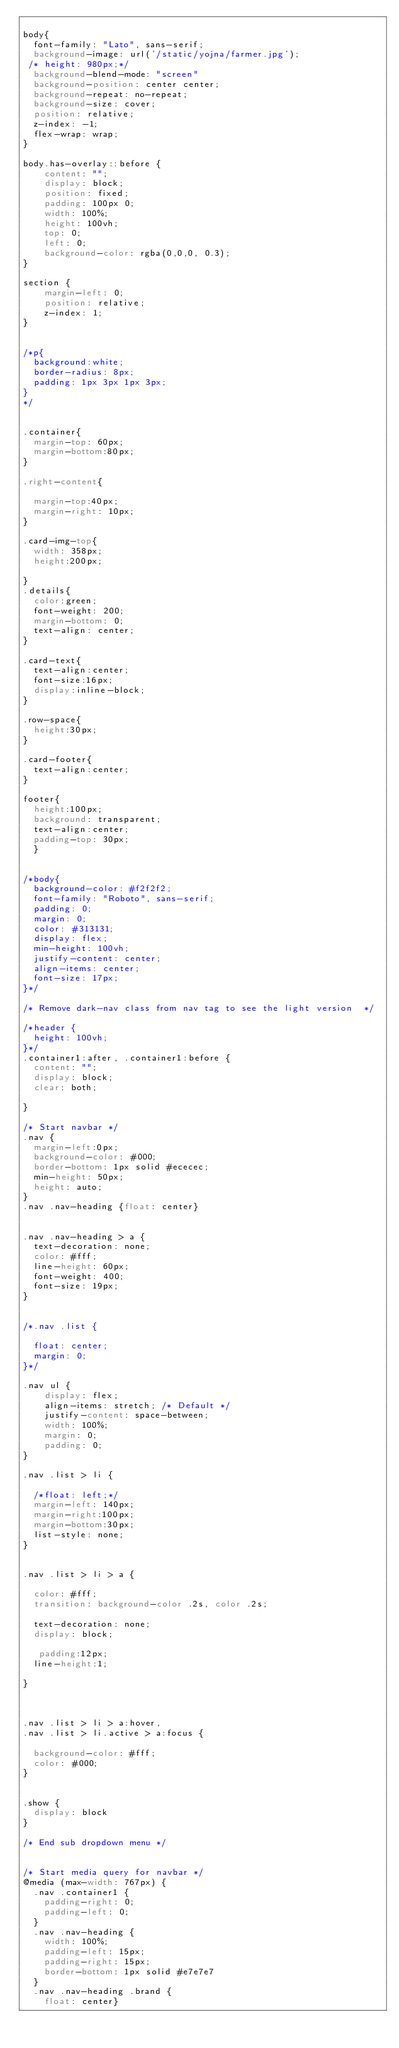Convert code to text. <code><loc_0><loc_0><loc_500><loc_500><_CSS_>
body{
  font-family: "Lato", sans-serif;
  background-image: url('/static/yojna/farmer.jpg');
 /* height: 980px;*/
  background-blend-mode: "screen"
  background-position: center center;
  background-repeat: no-repeat;
  background-size: cover;
  position: relative;
  z-index: -1;
  flex-wrap: wrap;
}

body.has-overlay::before {
    content: "";
    display: block;
    position: fixed;
    padding: 100px 0;
    width: 100%;
    height: 100vh;
    top: 0;
    left: 0;
    background-color: rgba(0,0,0, 0.3);
}

section {
    margin-left: 0;
    position: relative;
    z-index: 1;
}

  
/*p{
  background:white;
  border-radius: 8px;
  padding: 1px 3px 1px 3px;
}
*/


.container{
  margin-top: 60px;
  margin-bottom:80px;
}

.right-content{

  margin-top:40px;
  margin-right: 10px;
}

.card-img-top{
  width: 358px;
  height:200px;

}
.details{
  color:green;
  font-weight: 200;  
  margin-bottom: 0;
  text-align: center;
}

.card-text{
  text-align:center;
  font-size:16px;
  display:inline-block;
}

.row-space{
  height:30px;
}

.card-footer{
  text-align:center;
}

footer{
  height:100px;
  background: transparent;
  text-align:center;
  padding-top: 30px;
  }


/*body{
  background-color: #f2f2f2;
  font-family: "Roboto", sans-serif;
  padding: 0;
  margin: 0;
  color: #313131;
  display: flex;
  min-height: 100vh;
  justify-content: center;
  align-items: center;
  font-size: 17px;
}*/

/* Remove dark-nav class from nav tag to see the light version  */

/*header {
  height: 100vh;
}*/
.container1:after, .container1:before {
  content: "";
  display: block;
  clear: both;

}

/* Start navbar */
.nav {
  margin-left:0px;
  background-color: #000;
  border-bottom: 1px solid #ececec;
  min-height: 50px;
  height: auto;
}
.nav .nav-heading {float: center}


.nav .nav-heading > a {
  text-decoration: none;
  color: #fff;
  line-height: 60px;
  font-weight: 400;
  font-size: 19px;
}


/*.nav .list {

  float: center;
  margin: 0;
}*/

.nav ul {
    display: flex;
    align-items: stretch; /* Default */
    justify-content: space-between;
    width: 100%;
    margin: 0;
    padding: 0;
}

.nav .list > li {
 
  /*float: left;*/
  margin-left: 140px;
  margin-right:100px;
  margin-bottom:30px;
  list-style: none;
}


.nav .list > li > a {
 
  color: #fff;
  transition: background-color .2s, color .2s;

  text-decoration: none;
  display: block;

   padding:12px;
  line-height:1;

}



.nav .list > li > a:hover,
.nav .list > li.active > a:focus {
 
  background-color: #fff;
  color: #000;
}


.show {
  display: block
}

/* End sub dropdown menu */


/* Start media query for navbar */
@media (max-width: 767px) {
  .nav .container1 {
    padding-right: 0;
    padding-left: 0;
  }
  .nav .nav-heading {
    width: 100%;
    padding-left: 15px;
    padding-right: 15px;
    border-bottom: 1px solid #e7e7e7
  }
  .nav .nav-heading .brand {
    float: center}




</code> 